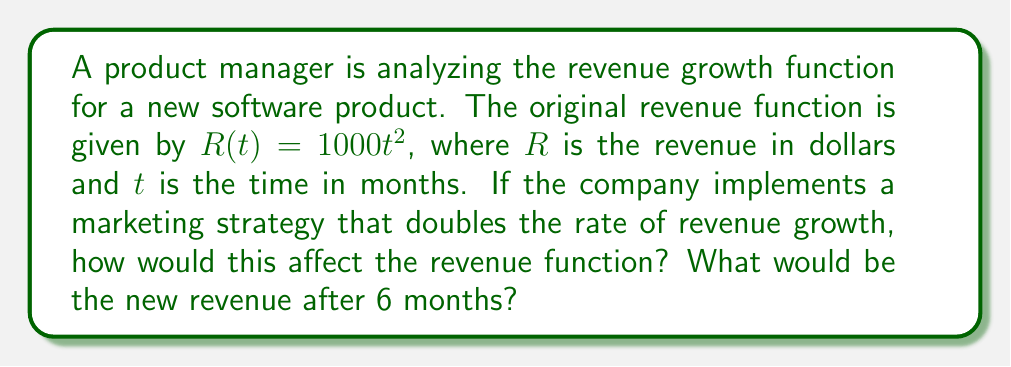Teach me how to tackle this problem. 1) The original revenue function is $R(t) = 1000t^2$.

2) Doubling the rate of revenue growth is equivalent to applying a dilation with a scale factor of 2 to the input variable. This can be represented as:

   $R_{new}(t) = 1000(2t)^2$

3) Let's simplify this new function:
   
   $R_{new}(t) = 1000(2t)^2$
   $R_{new}(t) = 1000(4t^2)$
   $R_{new}(t) = 4000t^2$

4) To find the revenue after 6 months, we substitute $t = 6$ into the new function:

   $R_{new}(6) = 4000(6)^2$
   $R_{new}(6) = 4000(36)$
   $R_{new}(6) = 144,000$

5) Therefore, the new revenue after 6 months would be $144,000.

Note: This dilation effectively quadruples the original function, as $(2t)^2 = 4t^2$. This demonstrates how a change in growth rate can significantly impact revenue projections, which is crucial information for product management and customer satisfaction strategies.
Answer: $R_{new}(t) = 4000t^2$; $144,000 